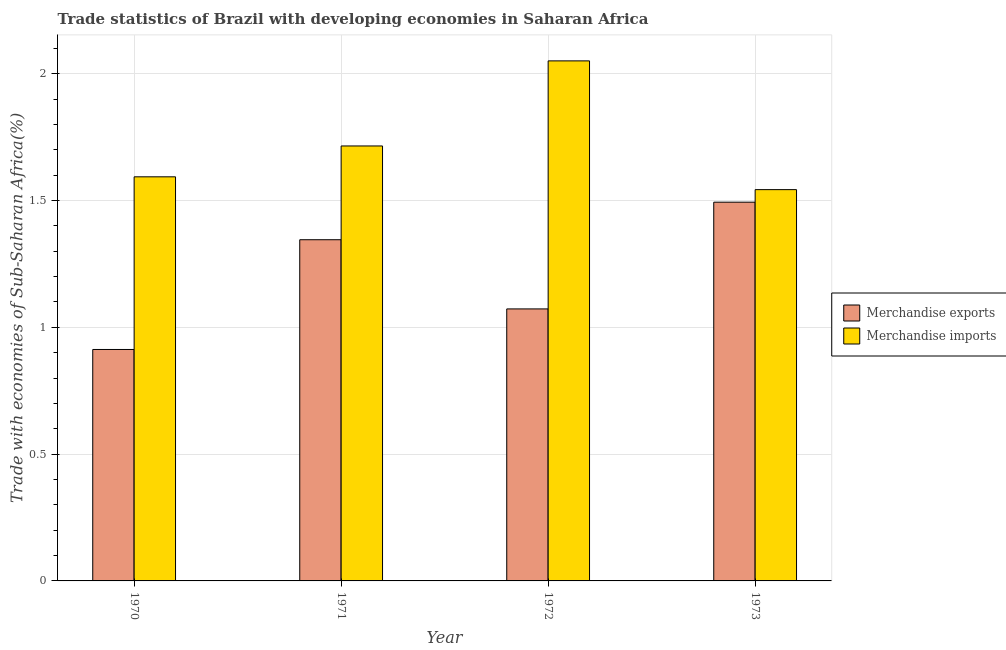How many bars are there on the 4th tick from the left?
Make the answer very short. 2. In how many cases, is the number of bars for a given year not equal to the number of legend labels?
Offer a terse response. 0. What is the merchandise imports in 1970?
Provide a short and direct response. 1.59. Across all years, what is the maximum merchandise exports?
Your response must be concise. 1.49. Across all years, what is the minimum merchandise exports?
Keep it short and to the point. 0.91. What is the total merchandise exports in the graph?
Give a very brief answer. 4.82. What is the difference between the merchandise imports in 1970 and that in 1971?
Ensure brevity in your answer.  -0.12. What is the difference between the merchandise exports in 1970 and the merchandise imports in 1973?
Give a very brief answer. -0.58. What is the average merchandise imports per year?
Provide a succinct answer. 1.73. What is the ratio of the merchandise exports in 1970 to that in 1971?
Offer a very short reply. 0.68. Is the merchandise imports in 1970 less than that in 1972?
Offer a terse response. Yes. Is the difference between the merchandise imports in 1971 and 1973 greater than the difference between the merchandise exports in 1971 and 1973?
Your answer should be compact. No. What is the difference between the highest and the second highest merchandise imports?
Offer a terse response. 0.34. What is the difference between the highest and the lowest merchandise exports?
Your answer should be compact. 0.58. In how many years, is the merchandise imports greater than the average merchandise imports taken over all years?
Provide a short and direct response. 1. What does the 2nd bar from the right in 1970 represents?
Ensure brevity in your answer.  Merchandise exports. How many bars are there?
Provide a short and direct response. 8. How many years are there in the graph?
Your answer should be compact. 4. Does the graph contain grids?
Give a very brief answer. Yes. Where does the legend appear in the graph?
Ensure brevity in your answer.  Center right. How many legend labels are there?
Your answer should be very brief. 2. How are the legend labels stacked?
Your answer should be compact. Vertical. What is the title of the graph?
Keep it short and to the point. Trade statistics of Brazil with developing economies in Saharan Africa. Does "Ages 15-24" appear as one of the legend labels in the graph?
Provide a succinct answer. No. What is the label or title of the Y-axis?
Give a very brief answer. Trade with economies of Sub-Saharan Africa(%). What is the Trade with economies of Sub-Saharan Africa(%) in Merchandise exports in 1970?
Your answer should be very brief. 0.91. What is the Trade with economies of Sub-Saharan Africa(%) in Merchandise imports in 1970?
Offer a terse response. 1.59. What is the Trade with economies of Sub-Saharan Africa(%) in Merchandise exports in 1971?
Keep it short and to the point. 1.35. What is the Trade with economies of Sub-Saharan Africa(%) of Merchandise imports in 1971?
Your response must be concise. 1.72. What is the Trade with economies of Sub-Saharan Africa(%) in Merchandise exports in 1972?
Your response must be concise. 1.07. What is the Trade with economies of Sub-Saharan Africa(%) in Merchandise imports in 1972?
Ensure brevity in your answer.  2.05. What is the Trade with economies of Sub-Saharan Africa(%) in Merchandise exports in 1973?
Offer a very short reply. 1.49. What is the Trade with economies of Sub-Saharan Africa(%) in Merchandise imports in 1973?
Offer a terse response. 1.54. Across all years, what is the maximum Trade with economies of Sub-Saharan Africa(%) in Merchandise exports?
Your answer should be compact. 1.49. Across all years, what is the maximum Trade with economies of Sub-Saharan Africa(%) in Merchandise imports?
Provide a succinct answer. 2.05. Across all years, what is the minimum Trade with economies of Sub-Saharan Africa(%) in Merchandise exports?
Your answer should be compact. 0.91. Across all years, what is the minimum Trade with economies of Sub-Saharan Africa(%) of Merchandise imports?
Your response must be concise. 1.54. What is the total Trade with economies of Sub-Saharan Africa(%) of Merchandise exports in the graph?
Keep it short and to the point. 4.82. What is the total Trade with economies of Sub-Saharan Africa(%) of Merchandise imports in the graph?
Ensure brevity in your answer.  6.9. What is the difference between the Trade with economies of Sub-Saharan Africa(%) of Merchandise exports in 1970 and that in 1971?
Your answer should be very brief. -0.43. What is the difference between the Trade with economies of Sub-Saharan Africa(%) of Merchandise imports in 1970 and that in 1971?
Give a very brief answer. -0.12. What is the difference between the Trade with economies of Sub-Saharan Africa(%) of Merchandise exports in 1970 and that in 1972?
Keep it short and to the point. -0.16. What is the difference between the Trade with economies of Sub-Saharan Africa(%) of Merchandise imports in 1970 and that in 1972?
Your answer should be compact. -0.46. What is the difference between the Trade with economies of Sub-Saharan Africa(%) of Merchandise exports in 1970 and that in 1973?
Your answer should be compact. -0.58. What is the difference between the Trade with economies of Sub-Saharan Africa(%) in Merchandise imports in 1970 and that in 1973?
Your answer should be very brief. 0.05. What is the difference between the Trade with economies of Sub-Saharan Africa(%) of Merchandise exports in 1971 and that in 1972?
Ensure brevity in your answer.  0.27. What is the difference between the Trade with economies of Sub-Saharan Africa(%) of Merchandise imports in 1971 and that in 1972?
Offer a very short reply. -0.34. What is the difference between the Trade with economies of Sub-Saharan Africa(%) of Merchandise exports in 1971 and that in 1973?
Give a very brief answer. -0.15. What is the difference between the Trade with economies of Sub-Saharan Africa(%) of Merchandise imports in 1971 and that in 1973?
Give a very brief answer. 0.17. What is the difference between the Trade with economies of Sub-Saharan Africa(%) of Merchandise exports in 1972 and that in 1973?
Provide a succinct answer. -0.42. What is the difference between the Trade with economies of Sub-Saharan Africa(%) in Merchandise imports in 1972 and that in 1973?
Your response must be concise. 0.51. What is the difference between the Trade with economies of Sub-Saharan Africa(%) of Merchandise exports in 1970 and the Trade with economies of Sub-Saharan Africa(%) of Merchandise imports in 1971?
Your answer should be very brief. -0.8. What is the difference between the Trade with economies of Sub-Saharan Africa(%) of Merchandise exports in 1970 and the Trade with economies of Sub-Saharan Africa(%) of Merchandise imports in 1972?
Provide a short and direct response. -1.14. What is the difference between the Trade with economies of Sub-Saharan Africa(%) in Merchandise exports in 1970 and the Trade with economies of Sub-Saharan Africa(%) in Merchandise imports in 1973?
Ensure brevity in your answer.  -0.63. What is the difference between the Trade with economies of Sub-Saharan Africa(%) in Merchandise exports in 1971 and the Trade with economies of Sub-Saharan Africa(%) in Merchandise imports in 1972?
Give a very brief answer. -0.71. What is the difference between the Trade with economies of Sub-Saharan Africa(%) in Merchandise exports in 1971 and the Trade with economies of Sub-Saharan Africa(%) in Merchandise imports in 1973?
Your response must be concise. -0.2. What is the difference between the Trade with economies of Sub-Saharan Africa(%) in Merchandise exports in 1972 and the Trade with economies of Sub-Saharan Africa(%) in Merchandise imports in 1973?
Ensure brevity in your answer.  -0.47. What is the average Trade with economies of Sub-Saharan Africa(%) in Merchandise exports per year?
Offer a very short reply. 1.21. What is the average Trade with economies of Sub-Saharan Africa(%) of Merchandise imports per year?
Give a very brief answer. 1.73. In the year 1970, what is the difference between the Trade with economies of Sub-Saharan Africa(%) of Merchandise exports and Trade with economies of Sub-Saharan Africa(%) of Merchandise imports?
Keep it short and to the point. -0.68. In the year 1971, what is the difference between the Trade with economies of Sub-Saharan Africa(%) in Merchandise exports and Trade with economies of Sub-Saharan Africa(%) in Merchandise imports?
Make the answer very short. -0.37. In the year 1972, what is the difference between the Trade with economies of Sub-Saharan Africa(%) in Merchandise exports and Trade with economies of Sub-Saharan Africa(%) in Merchandise imports?
Offer a terse response. -0.98. In the year 1973, what is the difference between the Trade with economies of Sub-Saharan Africa(%) in Merchandise exports and Trade with economies of Sub-Saharan Africa(%) in Merchandise imports?
Give a very brief answer. -0.05. What is the ratio of the Trade with economies of Sub-Saharan Africa(%) in Merchandise exports in 1970 to that in 1971?
Your response must be concise. 0.68. What is the ratio of the Trade with economies of Sub-Saharan Africa(%) in Merchandise imports in 1970 to that in 1971?
Offer a terse response. 0.93. What is the ratio of the Trade with economies of Sub-Saharan Africa(%) in Merchandise exports in 1970 to that in 1972?
Provide a short and direct response. 0.85. What is the ratio of the Trade with economies of Sub-Saharan Africa(%) in Merchandise imports in 1970 to that in 1972?
Offer a very short reply. 0.78. What is the ratio of the Trade with economies of Sub-Saharan Africa(%) in Merchandise exports in 1970 to that in 1973?
Ensure brevity in your answer.  0.61. What is the ratio of the Trade with economies of Sub-Saharan Africa(%) in Merchandise imports in 1970 to that in 1973?
Your response must be concise. 1.03. What is the ratio of the Trade with economies of Sub-Saharan Africa(%) of Merchandise exports in 1971 to that in 1972?
Keep it short and to the point. 1.25. What is the ratio of the Trade with economies of Sub-Saharan Africa(%) in Merchandise imports in 1971 to that in 1972?
Your answer should be very brief. 0.84. What is the ratio of the Trade with economies of Sub-Saharan Africa(%) of Merchandise exports in 1971 to that in 1973?
Ensure brevity in your answer.  0.9. What is the ratio of the Trade with economies of Sub-Saharan Africa(%) in Merchandise imports in 1971 to that in 1973?
Give a very brief answer. 1.11. What is the ratio of the Trade with economies of Sub-Saharan Africa(%) in Merchandise exports in 1972 to that in 1973?
Provide a short and direct response. 0.72. What is the ratio of the Trade with economies of Sub-Saharan Africa(%) in Merchandise imports in 1972 to that in 1973?
Offer a terse response. 1.33. What is the difference between the highest and the second highest Trade with economies of Sub-Saharan Africa(%) in Merchandise exports?
Ensure brevity in your answer.  0.15. What is the difference between the highest and the second highest Trade with economies of Sub-Saharan Africa(%) of Merchandise imports?
Offer a very short reply. 0.34. What is the difference between the highest and the lowest Trade with economies of Sub-Saharan Africa(%) in Merchandise exports?
Give a very brief answer. 0.58. What is the difference between the highest and the lowest Trade with economies of Sub-Saharan Africa(%) in Merchandise imports?
Ensure brevity in your answer.  0.51. 